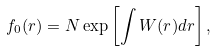Convert formula to latex. <formula><loc_0><loc_0><loc_500><loc_500>f _ { 0 } ( r ) = N \exp \left [ \int W ( r ) d r \right ] ,</formula> 